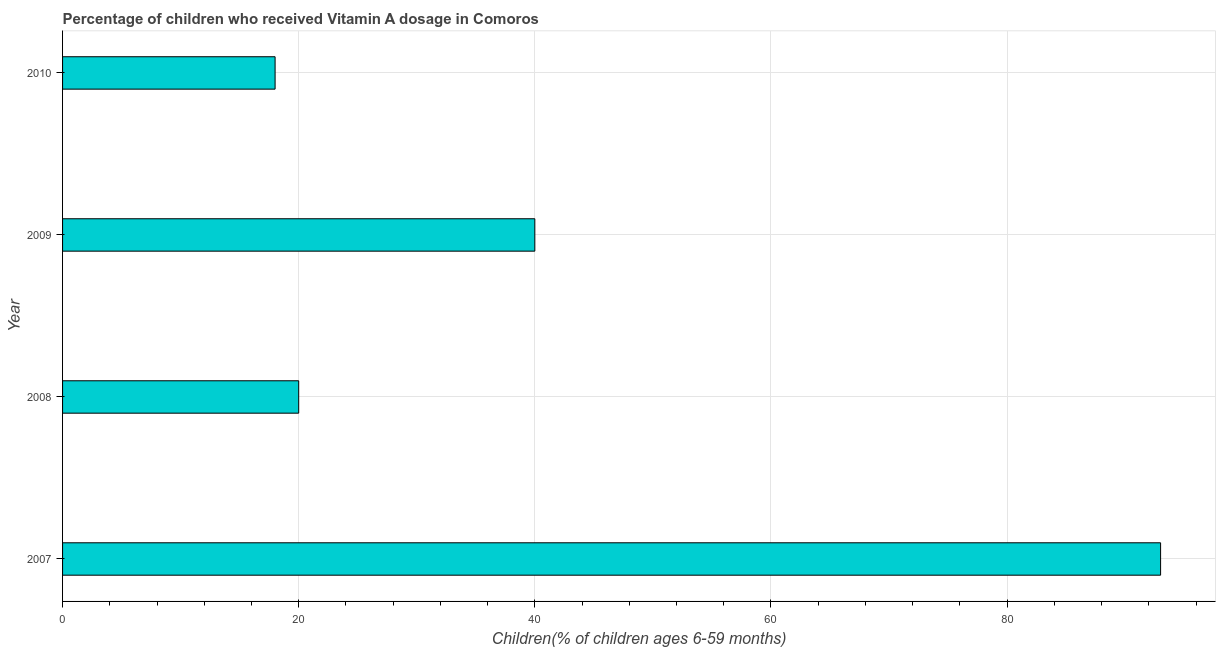Does the graph contain any zero values?
Provide a short and direct response. No. Does the graph contain grids?
Provide a short and direct response. Yes. What is the title of the graph?
Give a very brief answer. Percentage of children who received Vitamin A dosage in Comoros. What is the label or title of the X-axis?
Ensure brevity in your answer.  Children(% of children ages 6-59 months). What is the vitamin a supplementation coverage rate in 2010?
Make the answer very short. 18. Across all years, what is the maximum vitamin a supplementation coverage rate?
Provide a succinct answer. 93. In which year was the vitamin a supplementation coverage rate minimum?
Ensure brevity in your answer.  2010. What is the sum of the vitamin a supplementation coverage rate?
Ensure brevity in your answer.  171. What is the average vitamin a supplementation coverage rate per year?
Offer a very short reply. 42. In how many years, is the vitamin a supplementation coverage rate greater than 28 %?
Keep it short and to the point. 2. Do a majority of the years between 2008 and 2010 (inclusive) have vitamin a supplementation coverage rate greater than 20 %?
Make the answer very short. No. What is the ratio of the vitamin a supplementation coverage rate in 2009 to that in 2010?
Provide a short and direct response. 2.22. Is the vitamin a supplementation coverage rate in 2009 less than that in 2010?
Your answer should be very brief. No. Is the difference between the vitamin a supplementation coverage rate in 2008 and 2009 greater than the difference between any two years?
Ensure brevity in your answer.  No. What is the difference between the highest and the lowest vitamin a supplementation coverage rate?
Your response must be concise. 75. In how many years, is the vitamin a supplementation coverage rate greater than the average vitamin a supplementation coverage rate taken over all years?
Provide a short and direct response. 1. Are all the bars in the graph horizontal?
Your response must be concise. Yes. How many years are there in the graph?
Provide a short and direct response. 4. Are the values on the major ticks of X-axis written in scientific E-notation?
Make the answer very short. No. What is the Children(% of children ages 6-59 months) in 2007?
Your answer should be very brief. 93. What is the Children(% of children ages 6-59 months) of 2008?
Provide a short and direct response. 20. What is the difference between the Children(% of children ages 6-59 months) in 2007 and 2009?
Ensure brevity in your answer.  53. What is the difference between the Children(% of children ages 6-59 months) in 2007 and 2010?
Offer a terse response. 75. What is the difference between the Children(% of children ages 6-59 months) in 2008 and 2010?
Offer a terse response. 2. What is the difference between the Children(% of children ages 6-59 months) in 2009 and 2010?
Keep it short and to the point. 22. What is the ratio of the Children(% of children ages 6-59 months) in 2007 to that in 2008?
Make the answer very short. 4.65. What is the ratio of the Children(% of children ages 6-59 months) in 2007 to that in 2009?
Your answer should be very brief. 2.33. What is the ratio of the Children(% of children ages 6-59 months) in 2007 to that in 2010?
Your answer should be compact. 5.17. What is the ratio of the Children(% of children ages 6-59 months) in 2008 to that in 2010?
Your response must be concise. 1.11. What is the ratio of the Children(% of children ages 6-59 months) in 2009 to that in 2010?
Your answer should be compact. 2.22. 